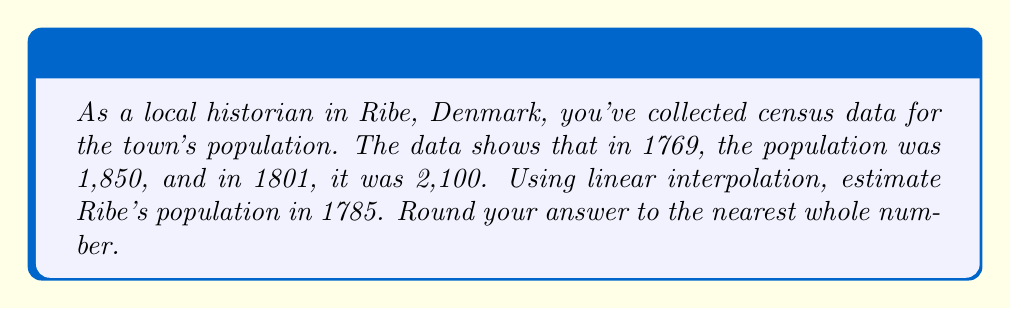Could you help me with this problem? Let's approach this step-by-step using linear interpolation:

1) Define our known points:
   $(x_1, y_1) = (1769, 1850)$
   $(x_2, y_2) = (1801, 2100)$

2) We want to find $y$ for $x = 1785$

3) The linear interpolation formula is:

   $$ y = y_1 + \frac{(x - x_1)(y_2 - y_1)}{(x_2 - x_1)} $$

4) Let's substitute our values:

   $$ y = 1850 + \frac{(1785 - 1769)(2100 - 1850)}{(1801 - 1769)} $$

5) Simplify:
   $$ y = 1850 + \frac{16 * 250}{32} $$

6) Calculate:
   $$ y = 1850 + 125 = 1975 $$

7) Round to the nearest whole number: 1975
Answer: 1,975 